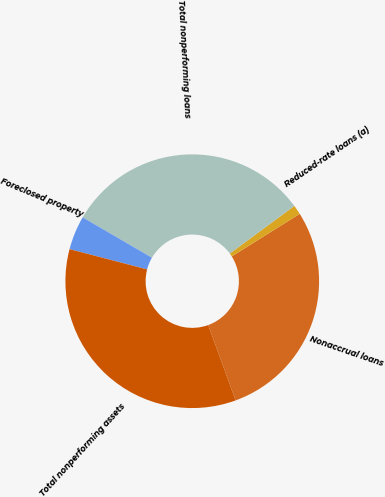Convert chart. <chart><loc_0><loc_0><loc_500><loc_500><pie_chart><fcel>Nonaccrual loans<fcel>Reduced-rate loans (a)<fcel>Total nonperforming loans<fcel>Foreclosed property<fcel>Total nonperforming assets<nl><fcel>28.36%<fcel>1.2%<fcel>31.49%<fcel>4.33%<fcel>34.62%<nl></chart> 